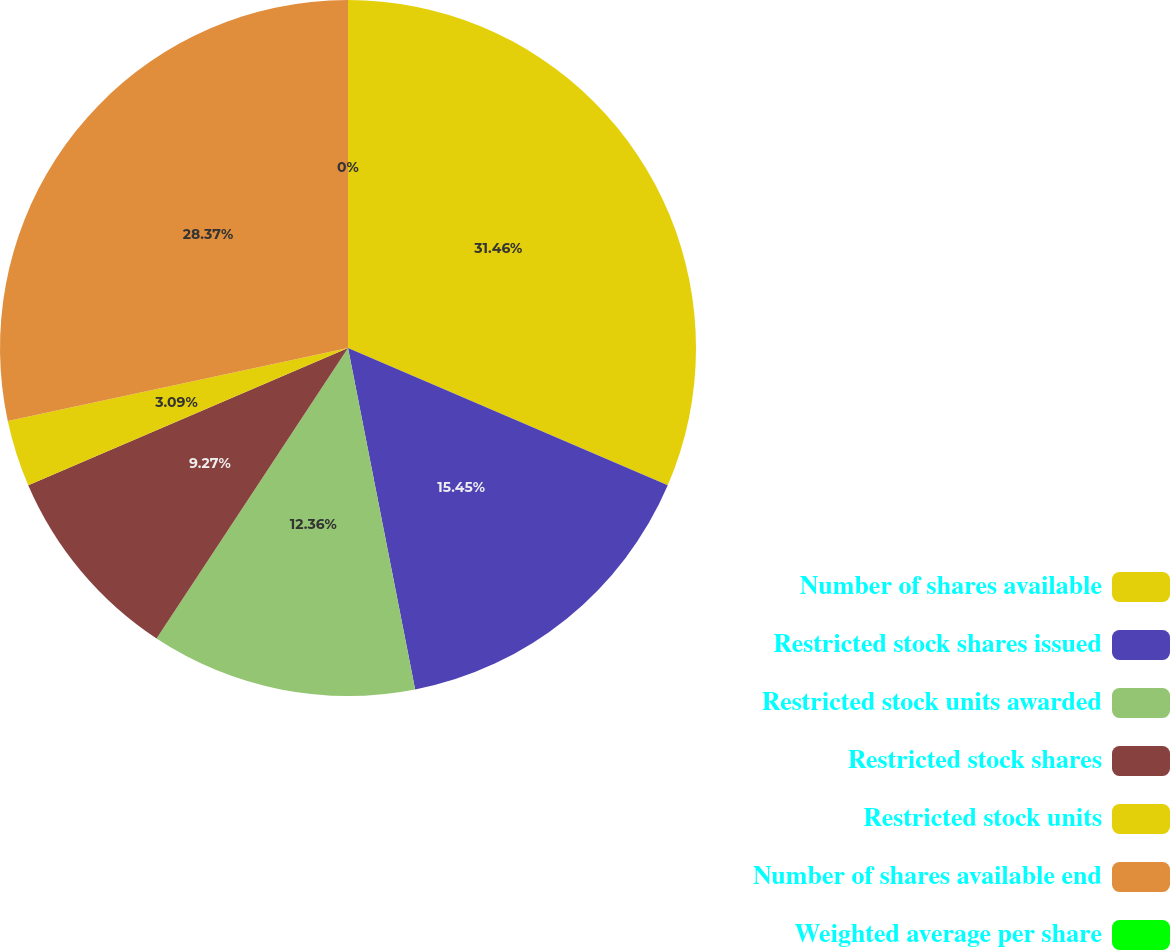Convert chart to OTSL. <chart><loc_0><loc_0><loc_500><loc_500><pie_chart><fcel>Number of shares available<fcel>Restricted stock shares issued<fcel>Restricted stock units awarded<fcel>Restricted stock shares<fcel>Restricted stock units<fcel>Number of shares available end<fcel>Weighted average per share<nl><fcel>31.45%<fcel>15.45%<fcel>12.36%<fcel>9.27%<fcel>3.09%<fcel>28.36%<fcel>0.0%<nl></chart> 